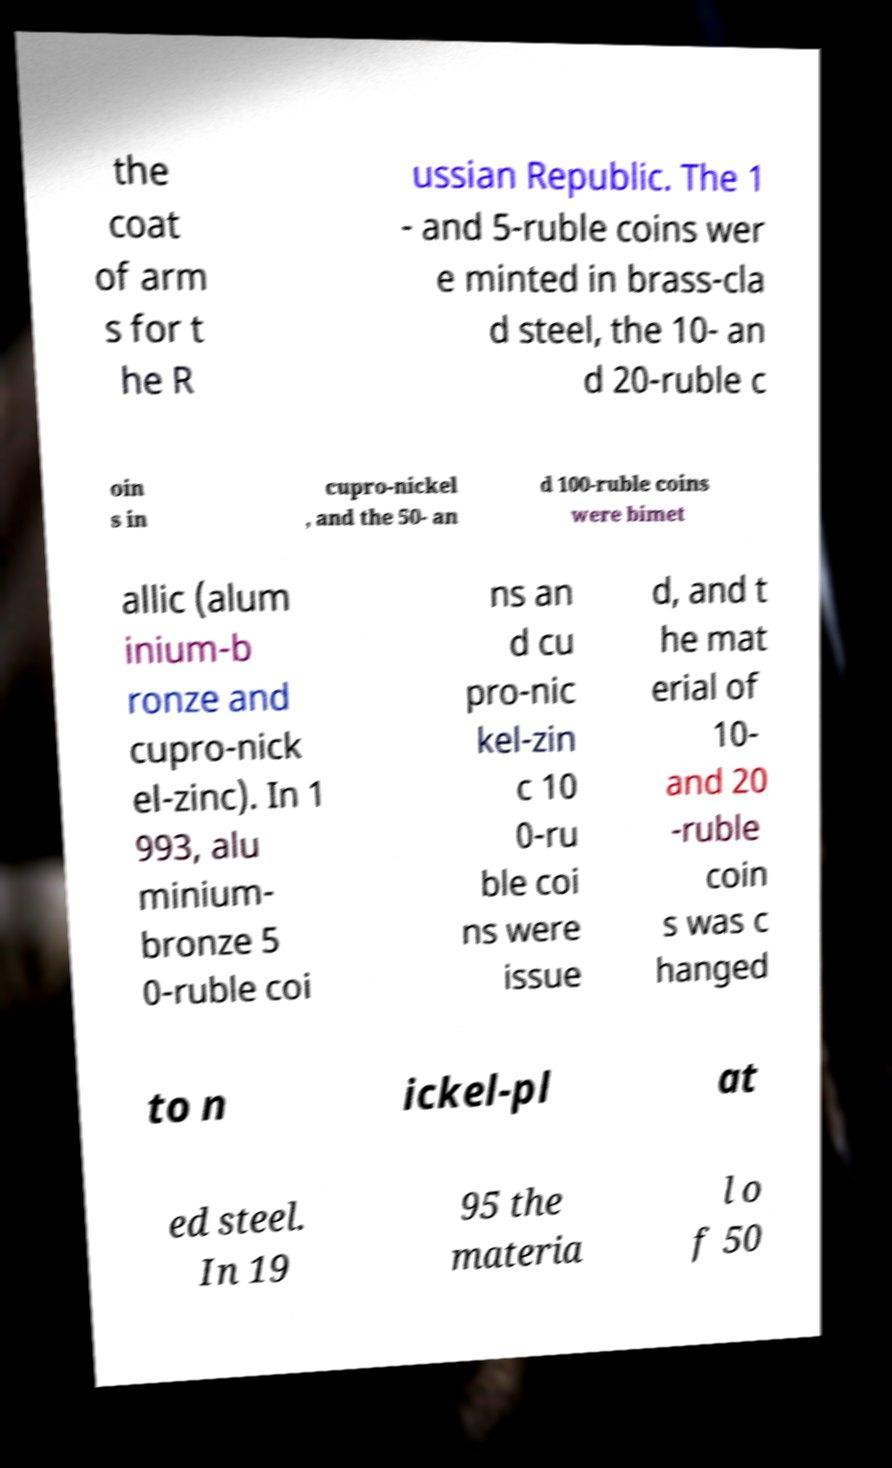Can you read and provide the text displayed in the image?This photo seems to have some interesting text. Can you extract and type it out for me? the coat of arm s for t he R ussian Republic. The 1 - and 5-ruble coins wer e minted in brass-cla d steel, the 10- an d 20-ruble c oin s in cupro-nickel , and the 50- an d 100-ruble coins were bimet allic (alum inium-b ronze and cupro-nick el-zinc). In 1 993, alu minium- bronze 5 0-ruble coi ns an d cu pro-nic kel-zin c 10 0-ru ble coi ns were issue d, and t he mat erial of 10- and 20 -ruble coin s was c hanged to n ickel-pl at ed steel. In 19 95 the materia l o f 50 